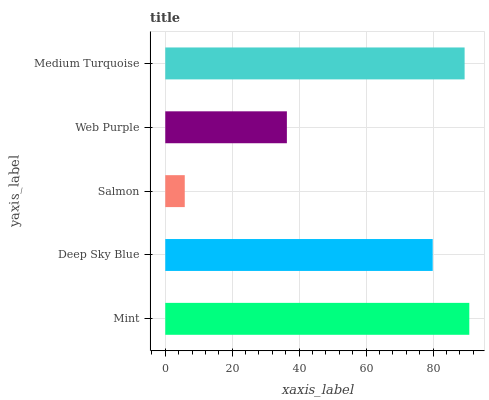Is Salmon the minimum?
Answer yes or no. Yes. Is Mint the maximum?
Answer yes or no. Yes. Is Deep Sky Blue the minimum?
Answer yes or no. No. Is Deep Sky Blue the maximum?
Answer yes or no. No. Is Mint greater than Deep Sky Blue?
Answer yes or no. Yes. Is Deep Sky Blue less than Mint?
Answer yes or no. Yes. Is Deep Sky Blue greater than Mint?
Answer yes or no. No. Is Mint less than Deep Sky Blue?
Answer yes or no. No. Is Deep Sky Blue the high median?
Answer yes or no. Yes. Is Deep Sky Blue the low median?
Answer yes or no. Yes. Is Mint the high median?
Answer yes or no. No. Is Web Purple the low median?
Answer yes or no. No. 